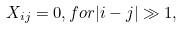<formula> <loc_0><loc_0><loc_500><loc_500>X _ { i j } = 0 , f o r | i - j | \gg 1 ,</formula> 